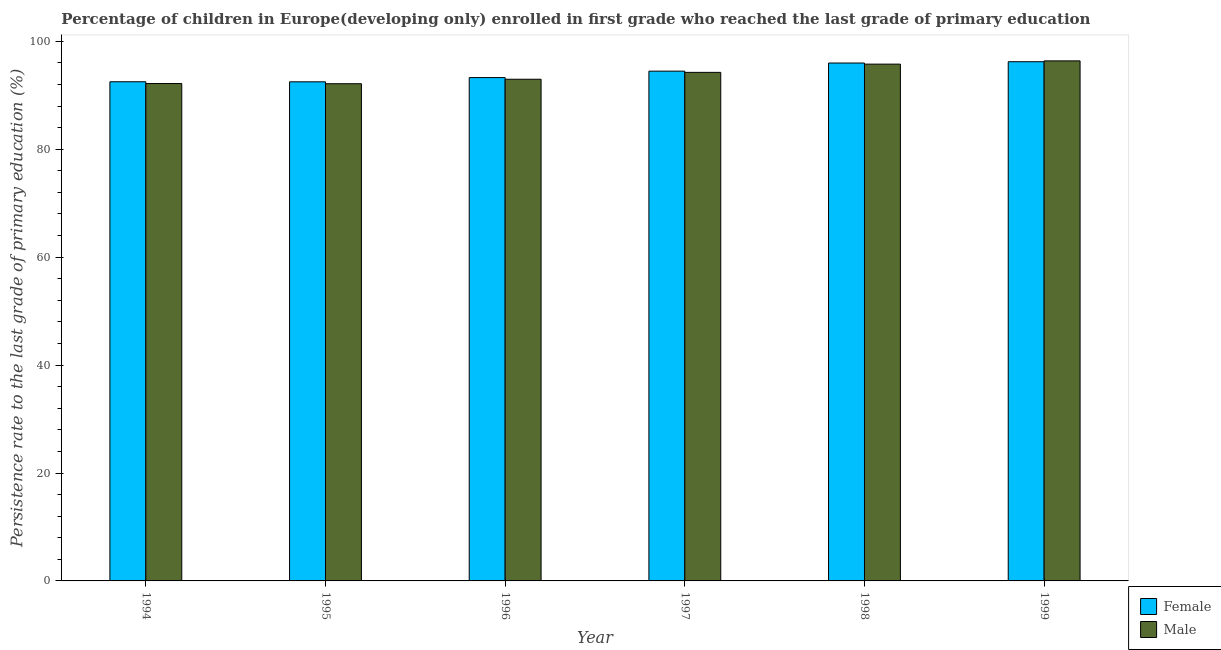How many different coloured bars are there?
Your answer should be compact. 2. How many groups of bars are there?
Your answer should be very brief. 6. Are the number of bars per tick equal to the number of legend labels?
Offer a very short reply. Yes. Are the number of bars on each tick of the X-axis equal?
Provide a succinct answer. Yes. What is the label of the 6th group of bars from the left?
Make the answer very short. 1999. What is the persistence rate of male students in 1996?
Provide a short and direct response. 92.97. Across all years, what is the maximum persistence rate of female students?
Give a very brief answer. 96.22. Across all years, what is the minimum persistence rate of male students?
Give a very brief answer. 92.14. In which year was the persistence rate of male students maximum?
Ensure brevity in your answer.  1999. What is the total persistence rate of male students in the graph?
Ensure brevity in your answer.  563.68. What is the difference between the persistence rate of male students in 1997 and that in 1998?
Provide a short and direct response. -1.53. What is the difference between the persistence rate of male students in 1996 and the persistence rate of female students in 1999?
Give a very brief answer. -3.4. What is the average persistence rate of male students per year?
Your response must be concise. 93.95. In the year 1999, what is the difference between the persistence rate of female students and persistence rate of male students?
Offer a very short reply. 0. What is the ratio of the persistence rate of female students in 1995 to that in 1999?
Provide a succinct answer. 0.96. Is the persistence rate of male students in 1994 less than that in 1999?
Your answer should be compact. Yes. Is the difference between the persistence rate of female students in 1997 and 1998 greater than the difference between the persistence rate of male students in 1997 and 1998?
Your answer should be very brief. No. What is the difference between the highest and the second highest persistence rate of male students?
Keep it short and to the point. 0.6. What is the difference between the highest and the lowest persistence rate of male students?
Your answer should be compact. 4.24. In how many years, is the persistence rate of female students greater than the average persistence rate of female students taken over all years?
Give a very brief answer. 3. Is the sum of the persistence rate of female students in 1996 and 1998 greater than the maximum persistence rate of male students across all years?
Make the answer very short. Yes. What does the 1st bar from the right in 1995 represents?
Make the answer very short. Male. Are all the bars in the graph horizontal?
Your answer should be very brief. No. Are the values on the major ticks of Y-axis written in scientific E-notation?
Give a very brief answer. No. Does the graph contain grids?
Your answer should be very brief. No. How many legend labels are there?
Your answer should be very brief. 2. What is the title of the graph?
Provide a succinct answer. Percentage of children in Europe(developing only) enrolled in first grade who reached the last grade of primary education. What is the label or title of the X-axis?
Your response must be concise. Year. What is the label or title of the Y-axis?
Give a very brief answer. Persistence rate to the last grade of primary education (%). What is the Persistence rate to the last grade of primary education (%) of Female in 1994?
Your answer should be very brief. 92.51. What is the Persistence rate to the last grade of primary education (%) of Male in 1994?
Your response must be concise. 92.18. What is the Persistence rate to the last grade of primary education (%) of Female in 1995?
Ensure brevity in your answer.  92.49. What is the Persistence rate to the last grade of primary education (%) in Male in 1995?
Offer a very short reply. 92.14. What is the Persistence rate to the last grade of primary education (%) of Female in 1996?
Provide a succinct answer. 93.28. What is the Persistence rate to the last grade of primary education (%) in Male in 1996?
Offer a very short reply. 92.97. What is the Persistence rate to the last grade of primary education (%) in Female in 1997?
Your response must be concise. 94.47. What is the Persistence rate to the last grade of primary education (%) of Male in 1997?
Provide a short and direct response. 94.25. What is the Persistence rate to the last grade of primary education (%) of Female in 1998?
Your answer should be compact. 95.98. What is the Persistence rate to the last grade of primary education (%) in Male in 1998?
Ensure brevity in your answer.  95.77. What is the Persistence rate to the last grade of primary education (%) in Female in 1999?
Your answer should be very brief. 96.22. What is the Persistence rate to the last grade of primary education (%) in Male in 1999?
Provide a succinct answer. 96.38. Across all years, what is the maximum Persistence rate to the last grade of primary education (%) in Female?
Ensure brevity in your answer.  96.22. Across all years, what is the maximum Persistence rate to the last grade of primary education (%) of Male?
Your response must be concise. 96.38. Across all years, what is the minimum Persistence rate to the last grade of primary education (%) of Female?
Ensure brevity in your answer.  92.49. Across all years, what is the minimum Persistence rate to the last grade of primary education (%) in Male?
Provide a succinct answer. 92.14. What is the total Persistence rate to the last grade of primary education (%) of Female in the graph?
Your answer should be compact. 564.95. What is the total Persistence rate to the last grade of primary education (%) in Male in the graph?
Your answer should be very brief. 563.68. What is the difference between the Persistence rate to the last grade of primary education (%) of Female in 1994 and that in 1995?
Give a very brief answer. 0.01. What is the difference between the Persistence rate to the last grade of primary education (%) of Male in 1994 and that in 1995?
Keep it short and to the point. 0.04. What is the difference between the Persistence rate to the last grade of primary education (%) in Female in 1994 and that in 1996?
Make the answer very short. -0.77. What is the difference between the Persistence rate to the last grade of primary education (%) of Male in 1994 and that in 1996?
Your answer should be compact. -0.8. What is the difference between the Persistence rate to the last grade of primary education (%) of Female in 1994 and that in 1997?
Your response must be concise. -1.96. What is the difference between the Persistence rate to the last grade of primary education (%) in Male in 1994 and that in 1997?
Your response must be concise. -2.07. What is the difference between the Persistence rate to the last grade of primary education (%) of Female in 1994 and that in 1998?
Provide a short and direct response. -3.47. What is the difference between the Persistence rate to the last grade of primary education (%) of Male in 1994 and that in 1998?
Make the answer very short. -3.6. What is the difference between the Persistence rate to the last grade of primary education (%) of Female in 1994 and that in 1999?
Your answer should be compact. -3.71. What is the difference between the Persistence rate to the last grade of primary education (%) in Male in 1994 and that in 1999?
Provide a succinct answer. -4.2. What is the difference between the Persistence rate to the last grade of primary education (%) in Female in 1995 and that in 1996?
Make the answer very short. -0.78. What is the difference between the Persistence rate to the last grade of primary education (%) in Male in 1995 and that in 1996?
Ensure brevity in your answer.  -0.83. What is the difference between the Persistence rate to the last grade of primary education (%) in Female in 1995 and that in 1997?
Provide a succinct answer. -1.98. What is the difference between the Persistence rate to the last grade of primary education (%) of Male in 1995 and that in 1997?
Ensure brevity in your answer.  -2.11. What is the difference between the Persistence rate to the last grade of primary education (%) in Female in 1995 and that in 1998?
Ensure brevity in your answer.  -3.49. What is the difference between the Persistence rate to the last grade of primary education (%) in Male in 1995 and that in 1998?
Keep it short and to the point. -3.63. What is the difference between the Persistence rate to the last grade of primary education (%) in Female in 1995 and that in 1999?
Offer a terse response. -3.73. What is the difference between the Persistence rate to the last grade of primary education (%) in Male in 1995 and that in 1999?
Offer a terse response. -4.24. What is the difference between the Persistence rate to the last grade of primary education (%) of Female in 1996 and that in 1997?
Offer a terse response. -1.19. What is the difference between the Persistence rate to the last grade of primary education (%) of Male in 1996 and that in 1997?
Your response must be concise. -1.27. What is the difference between the Persistence rate to the last grade of primary education (%) in Female in 1996 and that in 1998?
Your response must be concise. -2.7. What is the difference between the Persistence rate to the last grade of primary education (%) in Male in 1996 and that in 1998?
Your response must be concise. -2.8. What is the difference between the Persistence rate to the last grade of primary education (%) in Female in 1996 and that in 1999?
Offer a very short reply. -2.94. What is the difference between the Persistence rate to the last grade of primary education (%) in Male in 1996 and that in 1999?
Your answer should be very brief. -3.4. What is the difference between the Persistence rate to the last grade of primary education (%) in Female in 1997 and that in 1998?
Provide a succinct answer. -1.51. What is the difference between the Persistence rate to the last grade of primary education (%) of Male in 1997 and that in 1998?
Provide a short and direct response. -1.53. What is the difference between the Persistence rate to the last grade of primary education (%) of Female in 1997 and that in 1999?
Offer a terse response. -1.75. What is the difference between the Persistence rate to the last grade of primary education (%) in Male in 1997 and that in 1999?
Offer a very short reply. -2.13. What is the difference between the Persistence rate to the last grade of primary education (%) of Female in 1998 and that in 1999?
Provide a succinct answer. -0.24. What is the difference between the Persistence rate to the last grade of primary education (%) of Male in 1998 and that in 1999?
Offer a terse response. -0.6. What is the difference between the Persistence rate to the last grade of primary education (%) in Female in 1994 and the Persistence rate to the last grade of primary education (%) in Male in 1995?
Provide a succinct answer. 0.37. What is the difference between the Persistence rate to the last grade of primary education (%) of Female in 1994 and the Persistence rate to the last grade of primary education (%) of Male in 1996?
Offer a terse response. -0.47. What is the difference between the Persistence rate to the last grade of primary education (%) in Female in 1994 and the Persistence rate to the last grade of primary education (%) in Male in 1997?
Offer a very short reply. -1.74. What is the difference between the Persistence rate to the last grade of primary education (%) of Female in 1994 and the Persistence rate to the last grade of primary education (%) of Male in 1998?
Give a very brief answer. -3.27. What is the difference between the Persistence rate to the last grade of primary education (%) in Female in 1994 and the Persistence rate to the last grade of primary education (%) in Male in 1999?
Make the answer very short. -3.87. What is the difference between the Persistence rate to the last grade of primary education (%) of Female in 1995 and the Persistence rate to the last grade of primary education (%) of Male in 1996?
Your answer should be compact. -0.48. What is the difference between the Persistence rate to the last grade of primary education (%) of Female in 1995 and the Persistence rate to the last grade of primary education (%) of Male in 1997?
Provide a succinct answer. -1.75. What is the difference between the Persistence rate to the last grade of primary education (%) in Female in 1995 and the Persistence rate to the last grade of primary education (%) in Male in 1998?
Give a very brief answer. -3.28. What is the difference between the Persistence rate to the last grade of primary education (%) in Female in 1995 and the Persistence rate to the last grade of primary education (%) in Male in 1999?
Provide a short and direct response. -3.88. What is the difference between the Persistence rate to the last grade of primary education (%) in Female in 1996 and the Persistence rate to the last grade of primary education (%) in Male in 1997?
Keep it short and to the point. -0.97. What is the difference between the Persistence rate to the last grade of primary education (%) of Female in 1996 and the Persistence rate to the last grade of primary education (%) of Male in 1998?
Your answer should be compact. -2.49. What is the difference between the Persistence rate to the last grade of primary education (%) of Female in 1996 and the Persistence rate to the last grade of primary education (%) of Male in 1999?
Offer a very short reply. -3.1. What is the difference between the Persistence rate to the last grade of primary education (%) in Female in 1997 and the Persistence rate to the last grade of primary education (%) in Male in 1998?
Your answer should be very brief. -1.3. What is the difference between the Persistence rate to the last grade of primary education (%) in Female in 1997 and the Persistence rate to the last grade of primary education (%) in Male in 1999?
Your answer should be very brief. -1.9. What is the difference between the Persistence rate to the last grade of primary education (%) in Female in 1998 and the Persistence rate to the last grade of primary education (%) in Male in 1999?
Provide a short and direct response. -0.4. What is the average Persistence rate to the last grade of primary education (%) in Female per year?
Offer a terse response. 94.16. What is the average Persistence rate to the last grade of primary education (%) in Male per year?
Ensure brevity in your answer.  93.95. In the year 1994, what is the difference between the Persistence rate to the last grade of primary education (%) of Female and Persistence rate to the last grade of primary education (%) of Male?
Give a very brief answer. 0.33. In the year 1995, what is the difference between the Persistence rate to the last grade of primary education (%) of Female and Persistence rate to the last grade of primary education (%) of Male?
Your answer should be very brief. 0.35. In the year 1996, what is the difference between the Persistence rate to the last grade of primary education (%) of Female and Persistence rate to the last grade of primary education (%) of Male?
Ensure brevity in your answer.  0.31. In the year 1997, what is the difference between the Persistence rate to the last grade of primary education (%) of Female and Persistence rate to the last grade of primary education (%) of Male?
Ensure brevity in your answer.  0.23. In the year 1998, what is the difference between the Persistence rate to the last grade of primary education (%) in Female and Persistence rate to the last grade of primary education (%) in Male?
Your response must be concise. 0.21. In the year 1999, what is the difference between the Persistence rate to the last grade of primary education (%) in Female and Persistence rate to the last grade of primary education (%) in Male?
Make the answer very short. -0.15. What is the ratio of the Persistence rate to the last grade of primary education (%) in Female in 1994 to that in 1995?
Your answer should be very brief. 1. What is the ratio of the Persistence rate to the last grade of primary education (%) of Male in 1994 to that in 1995?
Keep it short and to the point. 1. What is the ratio of the Persistence rate to the last grade of primary education (%) of Female in 1994 to that in 1996?
Your answer should be compact. 0.99. What is the ratio of the Persistence rate to the last grade of primary education (%) in Female in 1994 to that in 1997?
Ensure brevity in your answer.  0.98. What is the ratio of the Persistence rate to the last grade of primary education (%) of Male in 1994 to that in 1997?
Your answer should be compact. 0.98. What is the ratio of the Persistence rate to the last grade of primary education (%) in Female in 1994 to that in 1998?
Provide a short and direct response. 0.96. What is the ratio of the Persistence rate to the last grade of primary education (%) of Male in 1994 to that in 1998?
Offer a very short reply. 0.96. What is the ratio of the Persistence rate to the last grade of primary education (%) in Female in 1994 to that in 1999?
Keep it short and to the point. 0.96. What is the ratio of the Persistence rate to the last grade of primary education (%) of Male in 1994 to that in 1999?
Your answer should be very brief. 0.96. What is the ratio of the Persistence rate to the last grade of primary education (%) in Female in 1995 to that in 1997?
Offer a very short reply. 0.98. What is the ratio of the Persistence rate to the last grade of primary education (%) in Male in 1995 to that in 1997?
Make the answer very short. 0.98. What is the ratio of the Persistence rate to the last grade of primary education (%) in Female in 1995 to that in 1998?
Make the answer very short. 0.96. What is the ratio of the Persistence rate to the last grade of primary education (%) of Male in 1995 to that in 1998?
Offer a very short reply. 0.96. What is the ratio of the Persistence rate to the last grade of primary education (%) of Female in 1995 to that in 1999?
Give a very brief answer. 0.96. What is the ratio of the Persistence rate to the last grade of primary education (%) in Male in 1995 to that in 1999?
Your answer should be compact. 0.96. What is the ratio of the Persistence rate to the last grade of primary education (%) in Female in 1996 to that in 1997?
Ensure brevity in your answer.  0.99. What is the ratio of the Persistence rate to the last grade of primary education (%) in Male in 1996 to that in 1997?
Make the answer very short. 0.99. What is the ratio of the Persistence rate to the last grade of primary education (%) in Female in 1996 to that in 1998?
Your answer should be very brief. 0.97. What is the ratio of the Persistence rate to the last grade of primary education (%) of Male in 1996 to that in 1998?
Ensure brevity in your answer.  0.97. What is the ratio of the Persistence rate to the last grade of primary education (%) in Female in 1996 to that in 1999?
Make the answer very short. 0.97. What is the ratio of the Persistence rate to the last grade of primary education (%) in Male in 1996 to that in 1999?
Your response must be concise. 0.96. What is the ratio of the Persistence rate to the last grade of primary education (%) in Female in 1997 to that in 1998?
Your answer should be very brief. 0.98. What is the ratio of the Persistence rate to the last grade of primary education (%) of Male in 1997 to that in 1998?
Your answer should be very brief. 0.98. What is the ratio of the Persistence rate to the last grade of primary education (%) of Female in 1997 to that in 1999?
Provide a short and direct response. 0.98. What is the ratio of the Persistence rate to the last grade of primary education (%) in Male in 1997 to that in 1999?
Give a very brief answer. 0.98. What is the ratio of the Persistence rate to the last grade of primary education (%) of Female in 1998 to that in 1999?
Offer a terse response. 1. What is the difference between the highest and the second highest Persistence rate to the last grade of primary education (%) in Female?
Ensure brevity in your answer.  0.24. What is the difference between the highest and the second highest Persistence rate to the last grade of primary education (%) of Male?
Your response must be concise. 0.6. What is the difference between the highest and the lowest Persistence rate to the last grade of primary education (%) of Female?
Ensure brevity in your answer.  3.73. What is the difference between the highest and the lowest Persistence rate to the last grade of primary education (%) of Male?
Your answer should be very brief. 4.24. 